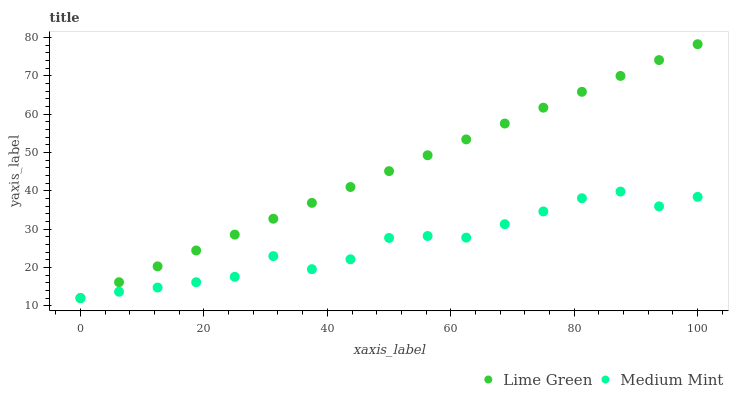Does Medium Mint have the minimum area under the curve?
Answer yes or no. Yes. Does Lime Green have the maximum area under the curve?
Answer yes or no. Yes. Does Lime Green have the minimum area under the curve?
Answer yes or no. No. Is Lime Green the smoothest?
Answer yes or no. Yes. Is Medium Mint the roughest?
Answer yes or no. Yes. Is Lime Green the roughest?
Answer yes or no. No. Does Medium Mint have the lowest value?
Answer yes or no. Yes. Does Lime Green have the highest value?
Answer yes or no. Yes. Does Medium Mint intersect Lime Green?
Answer yes or no. Yes. Is Medium Mint less than Lime Green?
Answer yes or no. No. Is Medium Mint greater than Lime Green?
Answer yes or no. No. 